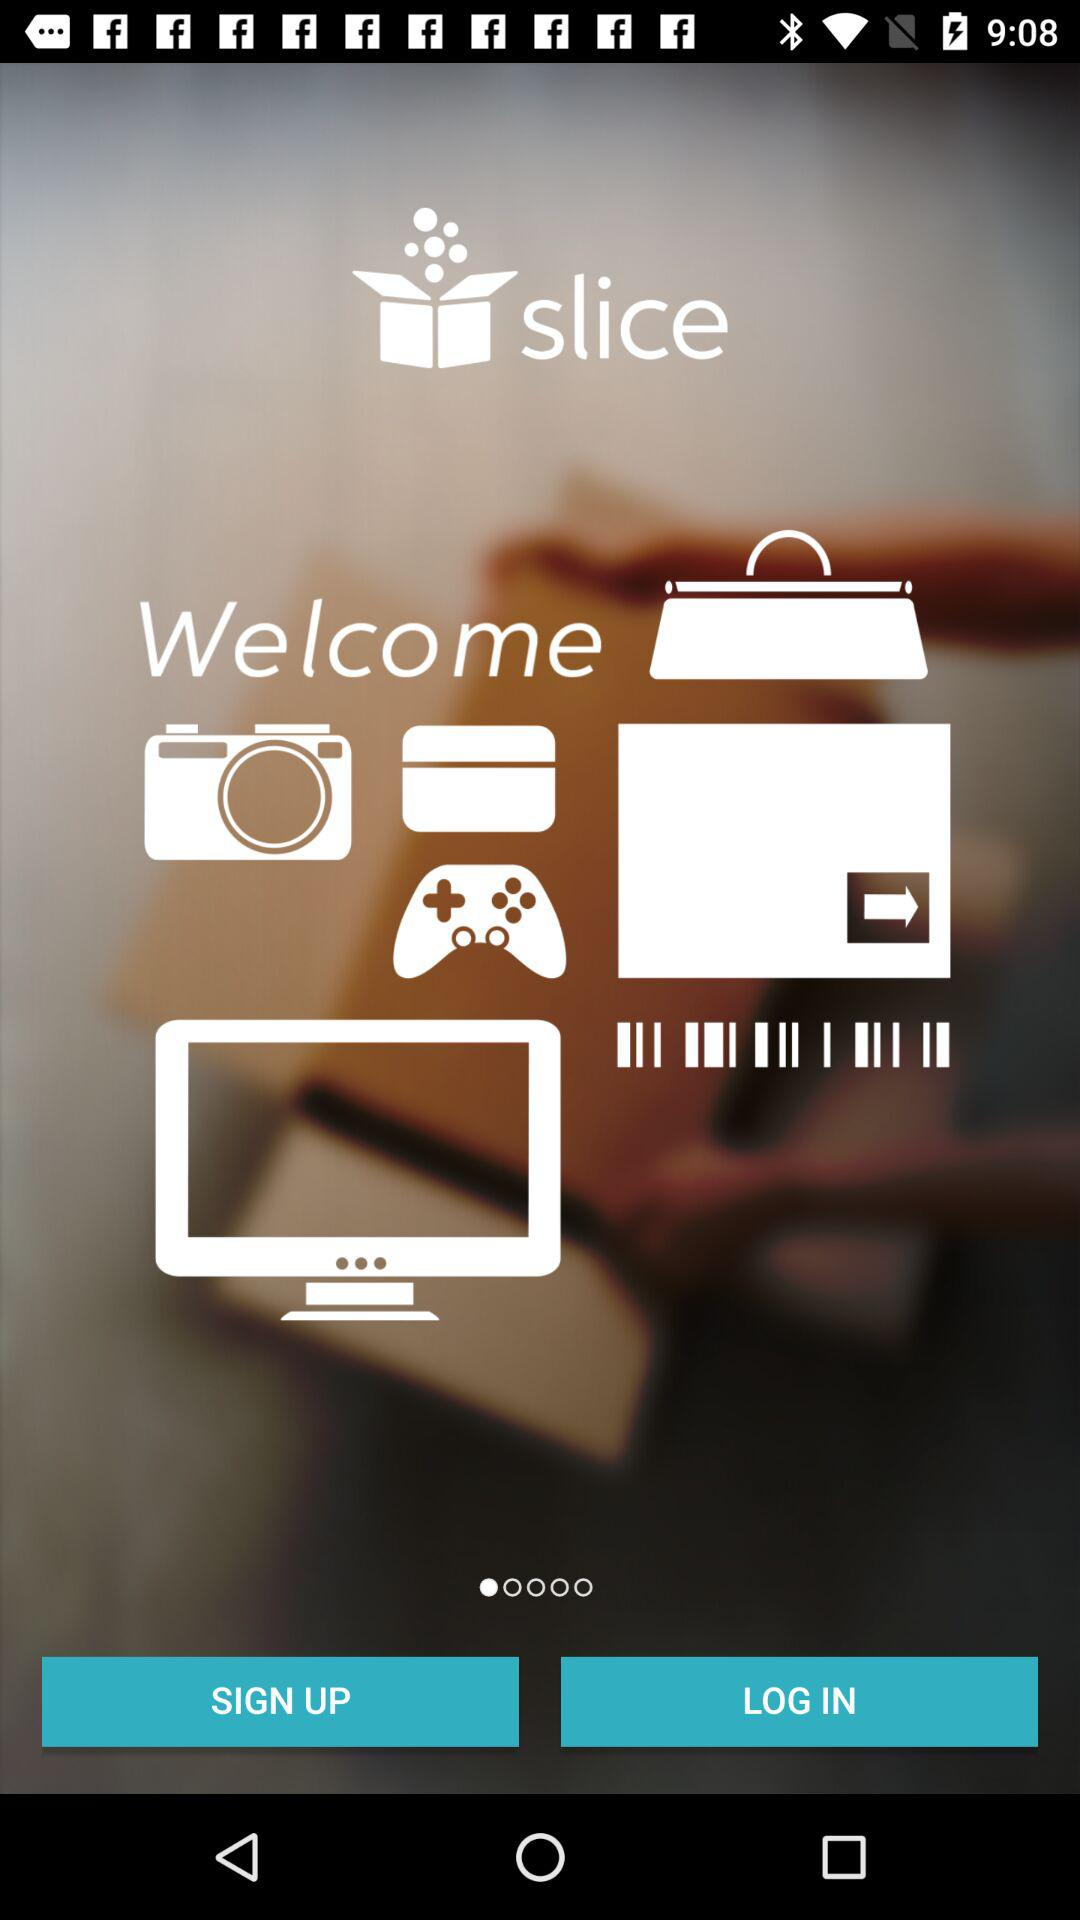What is the name of the application? The name of the application is "slice". 